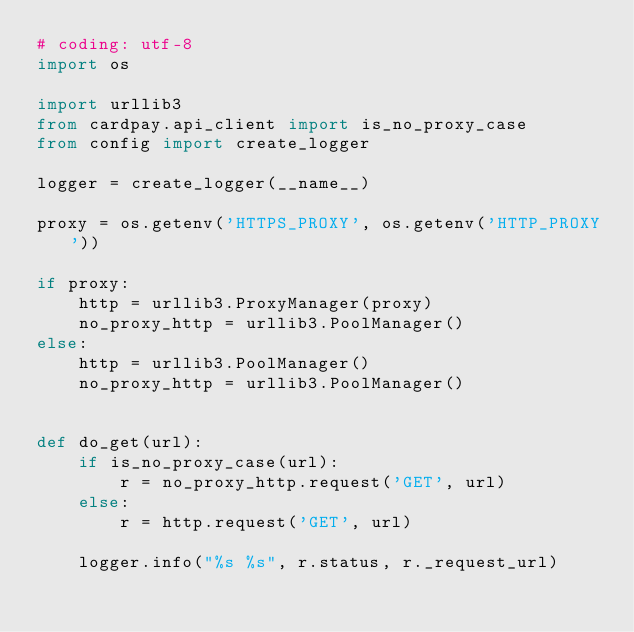Convert code to text. <code><loc_0><loc_0><loc_500><loc_500><_Python_># coding: utf-8
import os

import urllib3
from cardpay.api_client import is_no_proxy_case
from config import create_logger

logger = create_logger(__name__)

proxy = os.getenv('HTTPS_PROXY', os.getenv('HTTP_PROXY'))

if proxy:
    http = urllib3.ProxyManager(proxy)
    no_proxy_http = urllib3.PoolManager()
else:
    http = urllib3.PoolManager()
    no_proxy_http = urllib3.PoolManager()


def do_get(url):
    if is_no_proxy_case(url):
        r = no_proxy_http.request('GET', url)
    else:
        r = http.request('GET', url)

    logger.info("%s %s", r.status, r._request_url)
</code> 